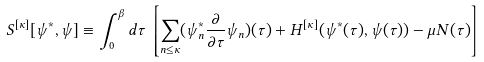Convert formula to latex. <formula><loc_0><loc_0><loc_500><loc_500>S ^ { [ \kappa ] } [ \psi ^ { * } , \psi ] \equiv \int _ { 0 } ^ { \beta } d \tau \, \left [ \sum _ { n \leq \kappa } ( \psi _ { n } ^ { * } \frac { \partial } { \partial \tau } \psi _ { n } ) ( \tau ) + H ^ { [ \kappa ] } ( \psi ^ { * } ( \tau ) , \psi ( \tau ) ) - \mu N ( \tau ) \right ]</formula> 